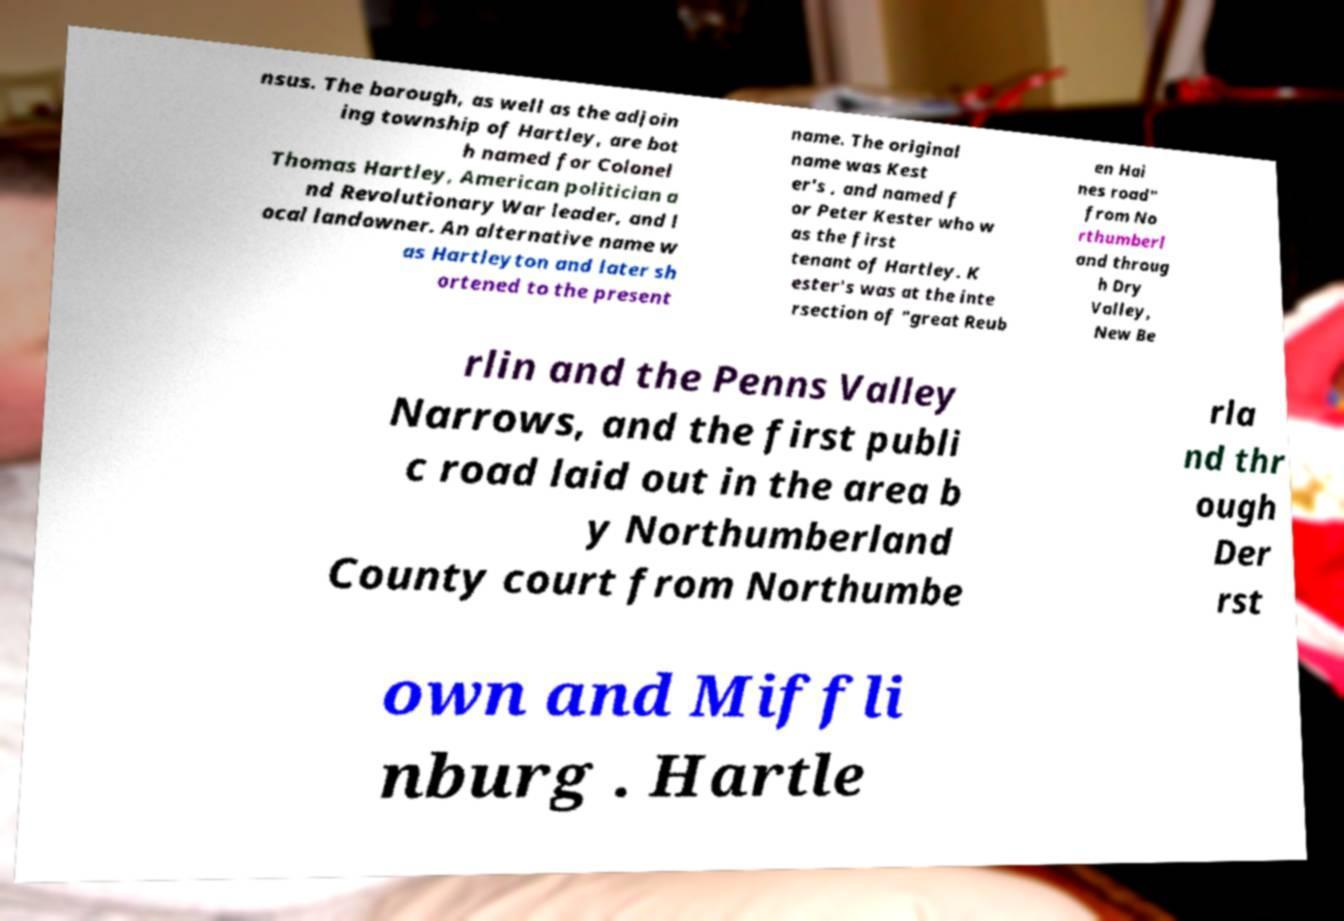Please identify and transcribe the text found in this image. nsus. The borough, as well as the adjoin ing township of Hartley, are bot h named for Colonel Thomas Hartley, American politician a nd Revolutionary War leader, and l ocal landowner. An alternative name w as Hartleyton and later sh ortened to the present name. The original name was Kest er's , and named f or Peter Kester who w as the first tenant of Hartley. K ester's was at the inte rsection of "great Reub en Hai nes road" from No rthumberl and throug h Dry Valley, New Be rlin and the Penns Valley Narrows, and the first publi c road laid out in the area b y Northumberland County court from Northumbe rla nd thr ough Der rst own and Miffli nburg . Hartle 